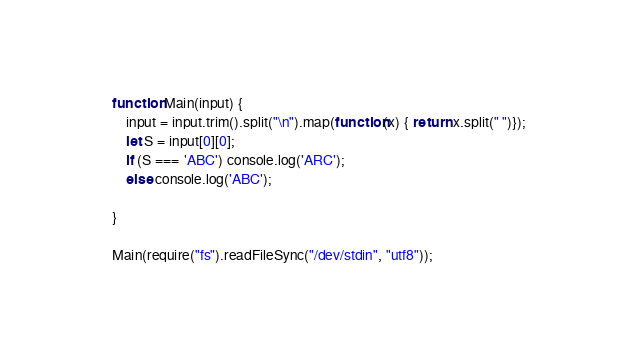Convert code to text. <code><loc_0><loc_0><loc_500><loc_500><_JavaScript_>function Main(input) {
	input = input.trim().split("\n").map(function(x) { return x.split(" ")});
    let S = input[0][0];
    if (S === 'ABC') console.log('ARC');
    else console.log('ABC');

}

Main(require("fs").readFileSync("/dev/stdin", "utf8"));
</code> 